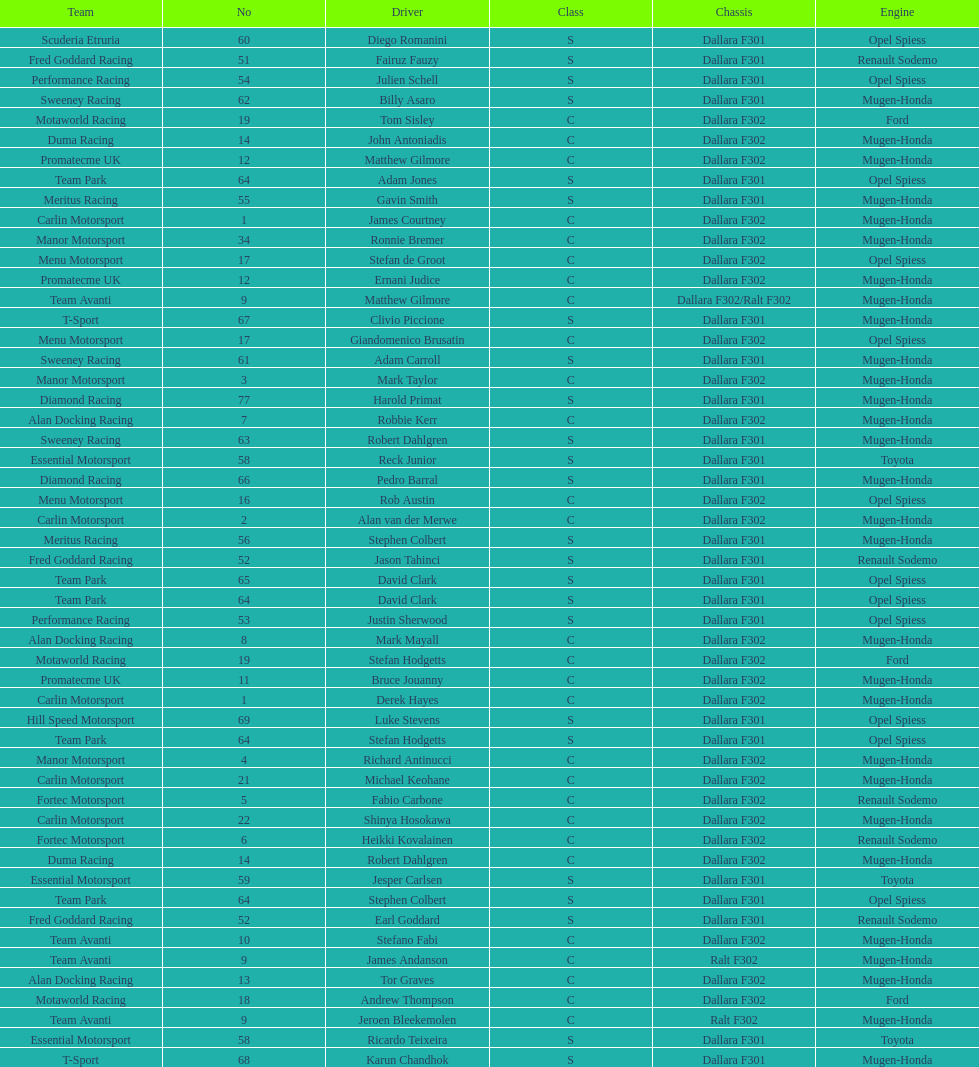What is the average number of teams that had a mugen-honda engine? 24. 